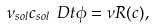<formula> <loc_0><loc_0><loc_500><loc_500>\nu _ { s o l } c _ { s o l } \ D t \phi = \nu R ( c ) ,</formula> 